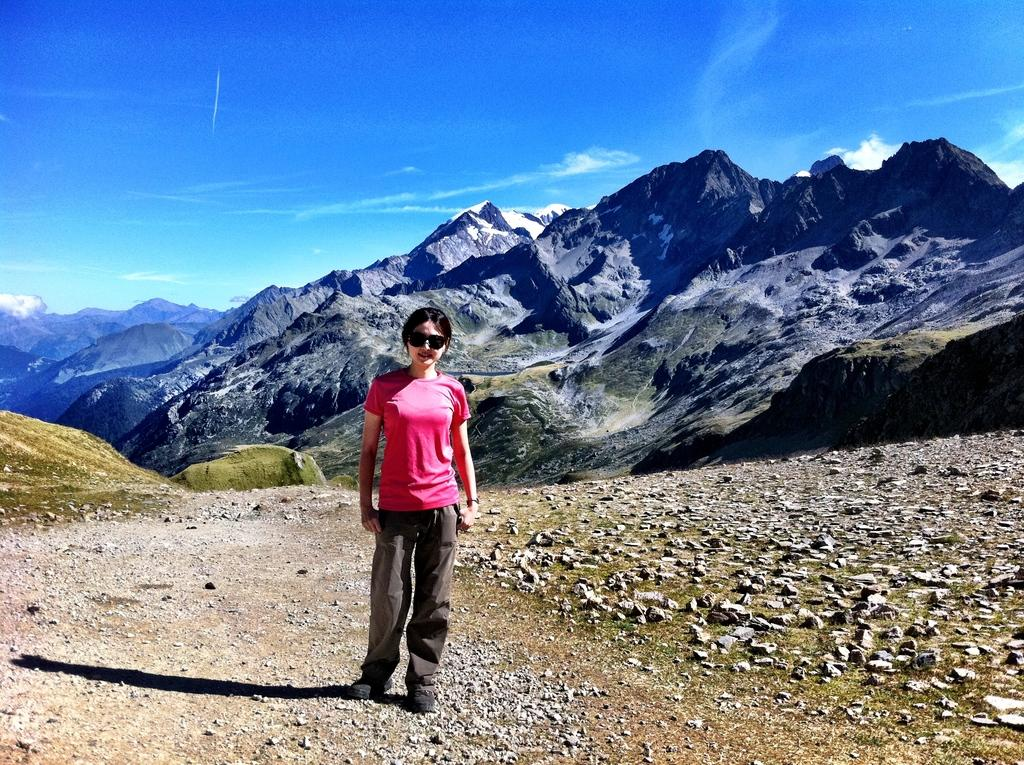Who is present in the image? There is a woman in the image. What is the woman doing in the image? The woman is standing and smiling. What is the woman wearing that is related to safety or protection? The woman is wearing goggles. What type of surface can be seen in the image? There are stones and a walkway visible in the image. What can be seen in the distance in the image? Hills and the sky are visible in the background of the image. What type of tin can be heard in the image? There is no tin present in the image, and therefore no sound can be heard. 